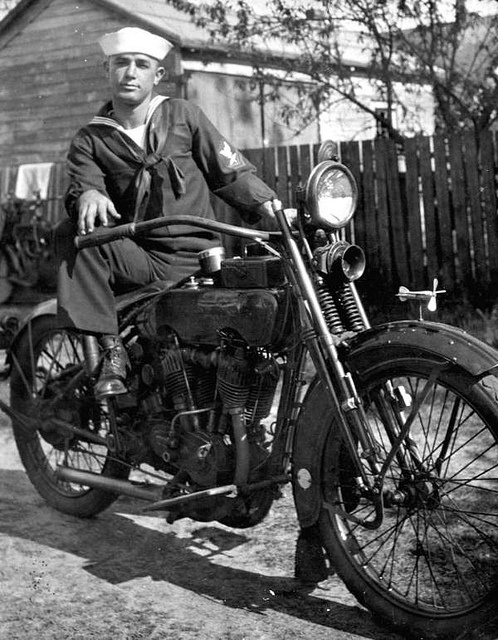Describe the objects in this image and their specific colors. I can see motorcycle in darkgray, black, gray, and lightgray tones and people in darkgray, gray, black, and lightgray tones in this image. 